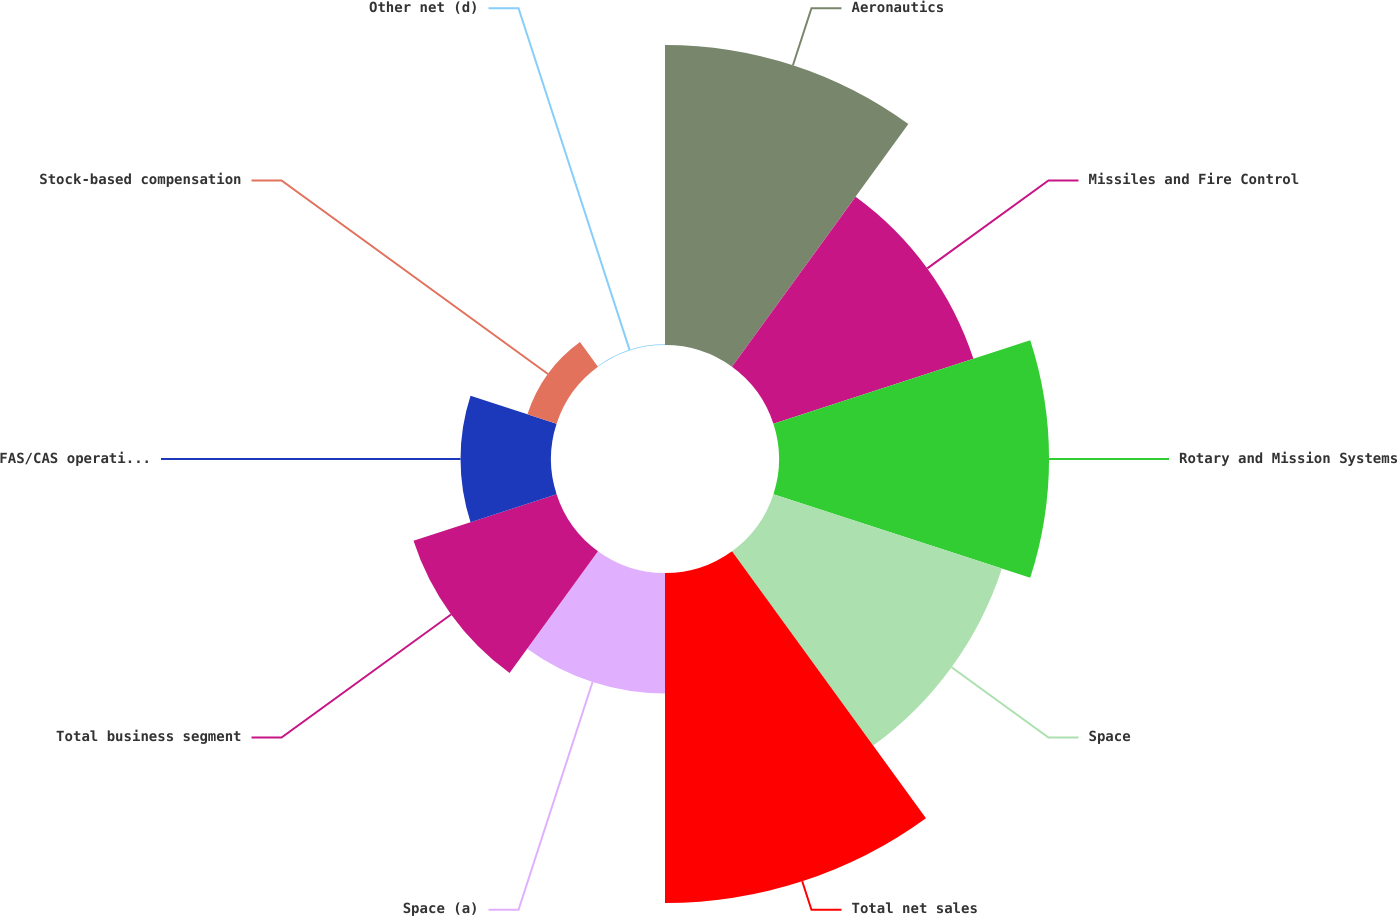<chart> <loc_0><loc_0><loc_500><loc_500><pie_chart><fcel>Aeronautics<fcel>Missiles and Fire Control<fcel>Rotary and Mission Systems<fcel>Space<fcel>Total net sales<fcel>Space (a)<fcel>Total business segment<fcel>FAS/CAS operating adjustment<fcel>Stock-based compensation<fcel>Other net (d)<nl><fcel>17.21%<fcel>12.06%<fcel>15.49%<fcel>13.78%<fcel>18.93%<fcel>6.91%<fcel>8.63%<fcel>5.19%<fcel>1.76%<fcel>0.04%<nl></chart> 